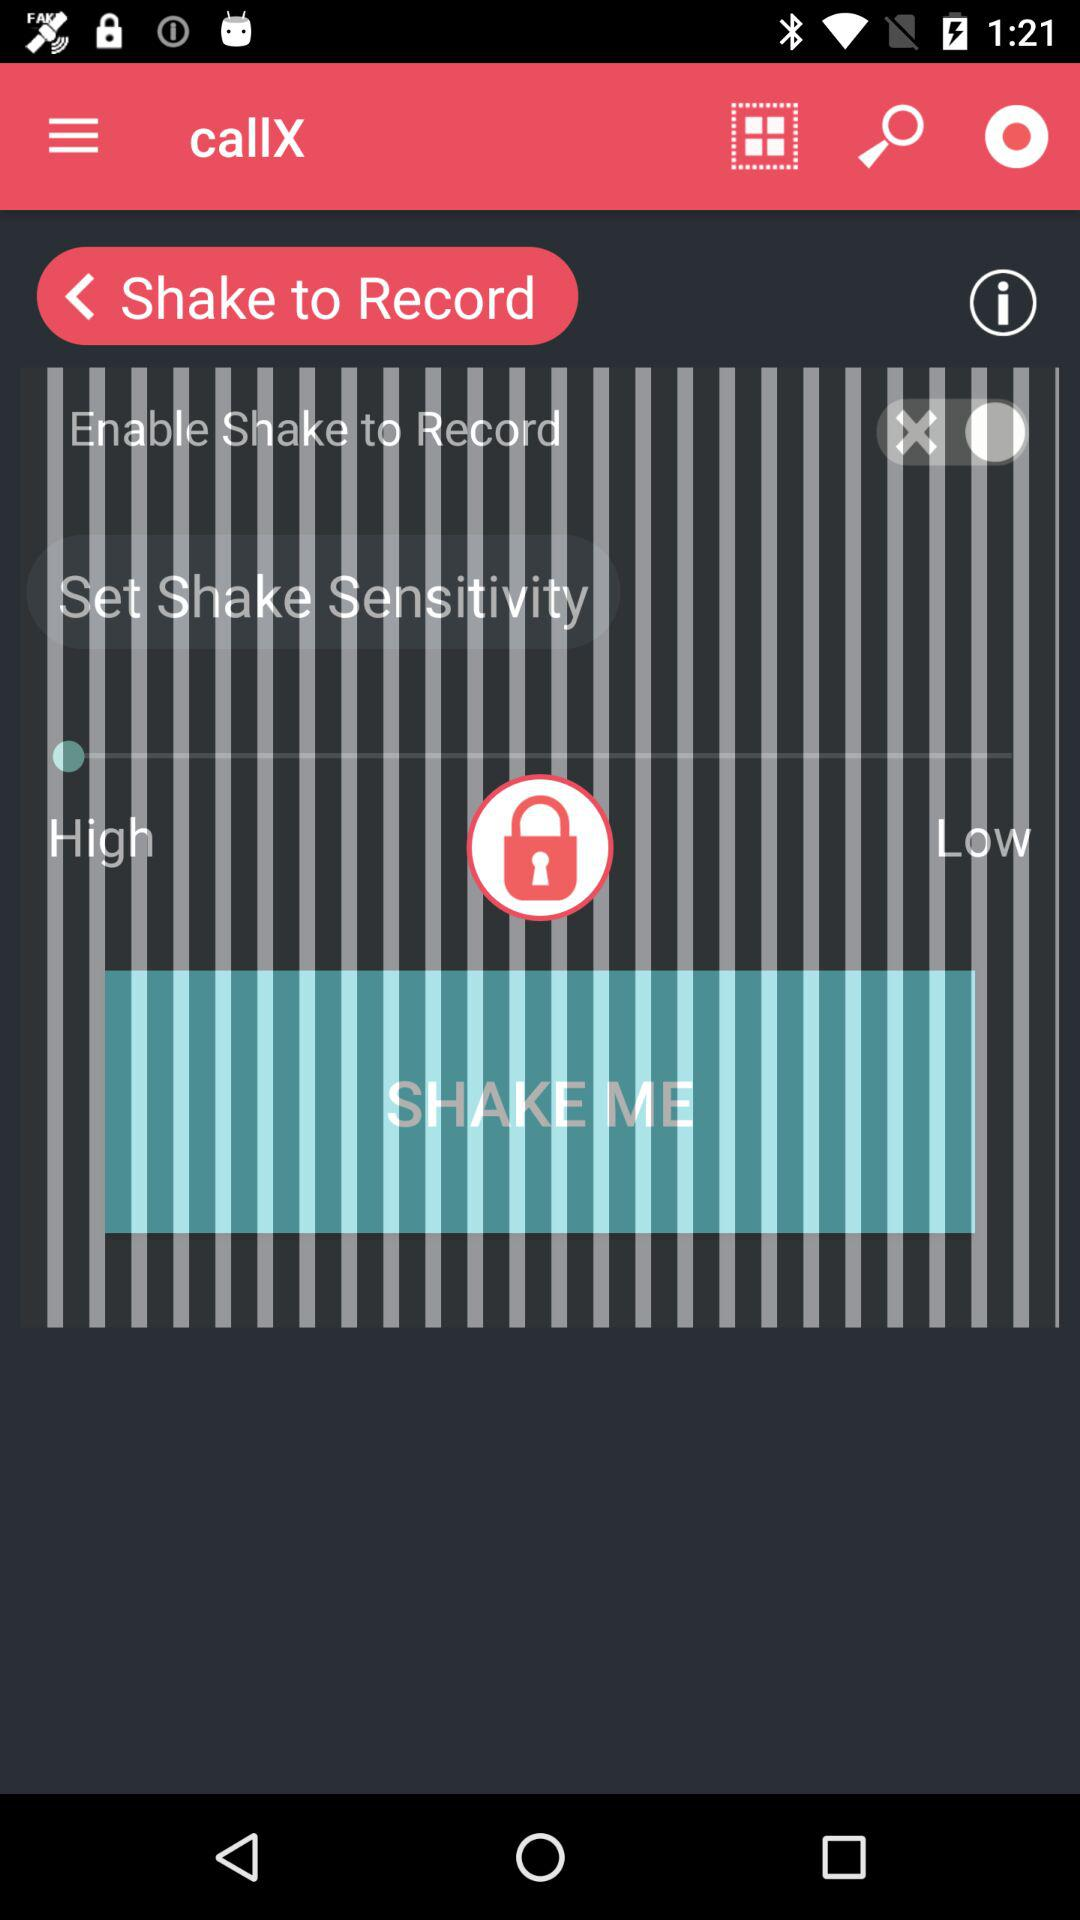What is the name of the application? The name of the application is "callX". 